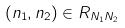<formula> <loc_0><loc_0><loc_500><loc_500>( n _ { 1 } , n _ { 2 } ) \in R _ { N _ { 1 } N _ { 2 } }</formula> 